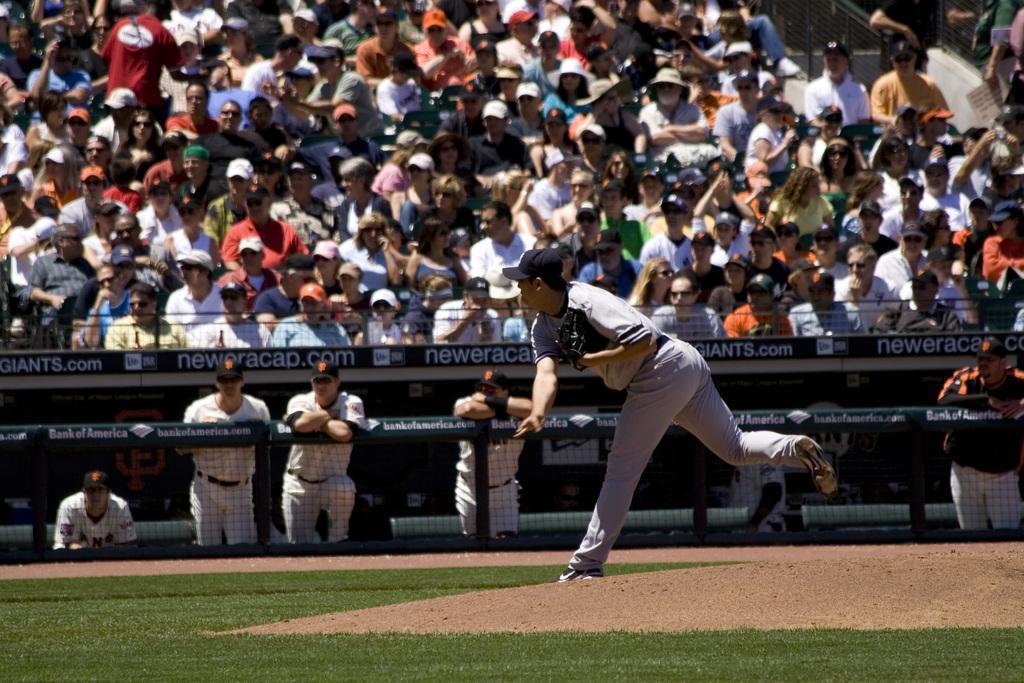In one or two sentences, can you explain what this image depicts? In this image I can see a group of people sitting. I can see few are standing and wearing a black glove. 